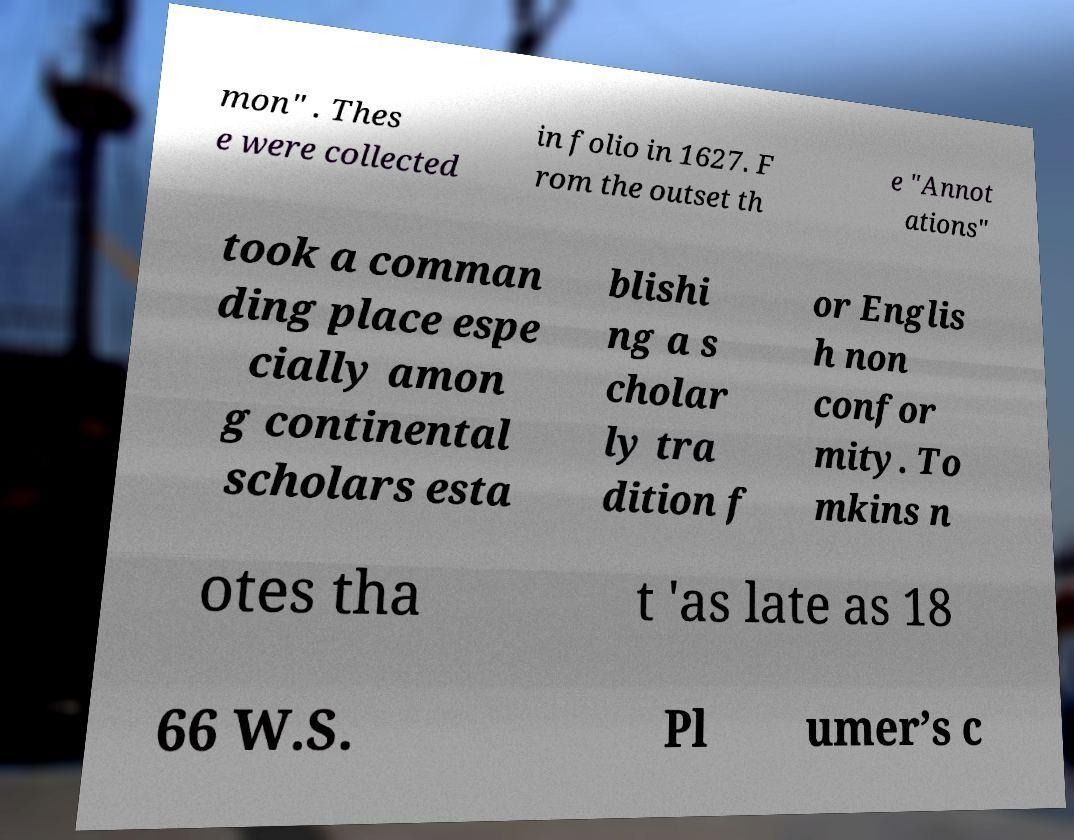Can you accurately transcribe the text from the provided image for me? mon" . Thes e were collected in folio in 1627. F rom the outset th e "Annot ations" took a comman ding place espe cially amon g continental scholars esta blishi ng a s cholar ly tra dition f or Englis h non confor mity. To mkins n otes tha t 'as late as 18 66 W.S. Pl umer’s c 